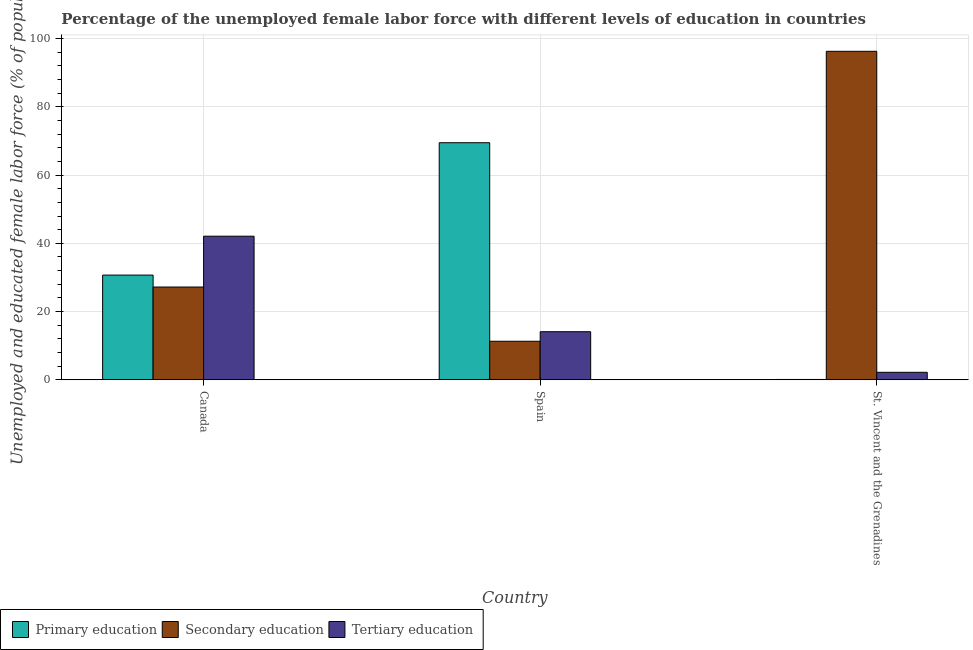How many different coloured bars are there?
Your answer should be very brief. 3. How many groups of bars are there?
Give a very brief answer. 3. How many bars are there on the 3rd tick from the left?
Keep it short and to the point. 3. In how many cases, is the number of bars for a given country not equal to the number of legend labels?
Make the answer very short. 0. What is the percentage of female labor force who received primary education in St. Vincent and the Grenadines?
Your answer should be compact. 0.1. Across all countries, what is the maximum percentage of female labor force who received secondary education?
Your answer should be very brief. 96.3. Across all countries, what is the minimum percentage of female labor force who received tertiary education?
Provide a short and direct response. 2.2. In which country was the percentage of female labor force who received primary education minimum?
Make the answer very short. St. Vincent and the Grenadines. What is the total percentage of female labor force who received secondary education in the graph?
Ensure brevity in your answer.  134.8. What is the difference between the percentage of female labor force who received primary education in Spain and that in St. Vincent and the Grenadines?
Make the answer very short. 69.4. What is the difference between the percentage of female labor force who received primary education in Canada and the percentage of female labor force who received secondary education in Spain?
Provide a short and direct response. 19.4. What is the average percentage of female labor force who received secondary education per country?
Offer a very short reply. 44.93. What is the difference between the percentage of female labor force who received secondary education and percentage of female labor force who received tertiary education in St. Vincent and the Grenadines?
Keep it short and to the point. 94.1. What is the ratio of the percentage of female labor force who received primary education in Canada to that in St. Vincent and the Grenadines?
Ensure brevity in your answer.  307. Is the percentage of female labor force who received secondary education in Canada less than that in Spain?
Offer a terse response. No. What is the difference between the highest and the second highest percentage of female labor force who received secondary education?
Provide a succinct answer. 69.1. What is the difference between the highest and the lowest percentage of female labor force who received primary education?
Provide a short and direct response. 69.4. Is the sum of the percentage of female labor force who received secondary education in Spain and St. Vincent and the Grenadines greater than the maximum percentage of female labor force who received primary education across all countries?
Your answer should be compact. Yes. What does the 1st bar from the left in Canada represents?
Give a very brief answer. Primary education. What does the 2nd bar from the right in St. Vincent and the Grenadines represents?
Keep it short and to the point. Secondary education. Is it the case that in every country, the sum of the percentage of female labor force who received primary education and percentage of female labor force who received secondary education is greater than the percentage of female labor force who received tertiary education?
Your answer should be compact. Yes. Does the graph contain grids?
Your response must be concise. Yes. How many legend labels are there?
Keep it short and to the point. 3. How are the legend labels stacked?
Your answer should be very brief. Horizontal. What is the title of the graph?
Ensure brevity in your answer.  Percentage of the unemployed female labor force with different levels of education in countries. What is the label or title of the X-axis?
Provide a short and direct response. Country. What is the label or title of the Y-axis?
Give a very brief answer. Unemployed and educated female labor force (% of population). What is the Unemployed and educated female labor force (% of population) in Primary education in Canada?
Your response must be concise. 30.7. What is the Unemployed and educated female labor force (% of population) in Secondary education in Canada?
Make the answer very short. 27.2. What is the Unemployed and educated female labor force (% of population) in Tertiary education in Canada?
Your answer should be compact. 42.1. What is the Unemployed and educated female labor force (% of population) of Primary education in Spain?
Offer a very short reply. 69.5. What is the Unemployed and educated female labor force (% of population) in Secondary education in Spain?
Your answer should be compact. 11.3. What is the Unemployed and educated female labor force (% of population) in Tertiary education in Spain?
Provide a succinct answer. 14.1. What is the Unemployed and educated female labor force (% of population) in Primary education in St. Vincent and the Grenadines?
Provide a succinct answer. 0.1. What is the Unemployed and educated female labor force (% of population) in Secondary education in St. Vincent and the Grenadines?
Give a very brief answer. 96.3. What is the Unemployed and educated female labor force (% of population) in Tertiary education in St. Vincent and the Grenadines?
Make the answer very short. 2.2. Across all countries, what is the maximum Unemployed and educated female labor force (% of population) of Primary education?
Provide a succinct answer. 69.5. Across all countries, what is the maximum Unemployed and educated female labor force (% of population) in Secondary education?
Ensure brevity in your answer.  96.3. Across all countries, what is the maximum Unemployed and educated female labor force (% of population) in Tertiary education?
Keep it short and to the point. 42.1. Across all countries, what is the minimum Unemployed and educated female labor force (% of population) of Primary education?
Your answer should be very brief. 0.1. Across all countries, what is the minimum Unemployed and educated female labor force (% of population) of Secondary education?
Give a very brief answer. 11.3. Across all countries, what is the minimum Unemployed and educated female labor force (% of population) of Tertiary education?
Provide a short and direct response. 2.2. What is the total Unemployed and educated female labor force (% of population) of Primary education in the graph?
Keep it short and to the point. 100.3. What is the total Unemployed and educated female labor force (% of population) in Secondary education in the graph?
Your answer should be compact. 134.8. What is the total Unemployed and educated female labor force (% of population) of Tertiary education in the graph?
Your answer should be compact. 58.4. What is the difference between the Unemployed and educated female labor force (% of population) of Primary education in Canada and that in Spain?
Offer a very short reply. -38.8. What is the difference between the Unemployed and educated female labor force (% of population) of Tertiary education in Canada and that in Spain?
Offer a terse response. 28. What is the difference between the Unemployed and educated female labor force (% of population) in Primary education in Canada and that in St. Vincent and the Grenadines?
Provide a short and direct response. 30.6. What is the difference between the Unemployed and educated female labor force (% of population) of Secondary education in Canada and that in St. Vincent and the Grenadines?
Offer a terse response. -69.1. What is the difference between the Unemployed and educated female labor force (% of population) of Tertiary education in Canada and that in St. Vincent and the Grenadines?
Your answer should be very brief. 39.9. What is the difference between the Unemployed and educated female labor force (% of population) of Primary education in Spain and that in St. Vincent and the Grenadines?
Offer a very short reply. 69.4. What is the difference between the Unemployed and educated female labor force (% of population) of Secondary education in Spain and that in St. Vincent and the Grenadines?
Your answer should be compact. -85. What is the difference between the Unemployed and educated female labor force (% of population) of Tertiary education in Spain and that in St. Vincent and the Grenadines?
Offer a very short reply. 11.9. What is the difference between the Unemployed and educated female labor force (% of population) of Primary education in Canada and the Unemployed and educated female labor force (% of population) of Secondary education in Spain?
Your answer should be very brief. 19.4. What is the difference between the Unemployed and educated female labor force (% of population) of Primary education in Canada and the Unemployed and educated female labor force (% of population) of Secondary education in St. Vincent and the Grenadines?
Offer a terse response. -65.6. What is the difference between the Unemployed and educated female labor force (% of population) in Primary education in Canada and the Unemployed and educated female labor force (% of population) in Tertiary education in St. Vincent and the Grenadines?
Ensure brevity in your answer.  28.5. What is the difference between the Unemployed and educated female labor force (% of population) in Primary education in Spain and the Unemployed and educated female labor force (% of population) in Secondary education in St. Vincent and the Grenadines?
Your answer should be very brief. -26.8. What is the difference between the Unemployed and educated female labor force (% of population) of Primary education in Spain and the Unemployed and educated female labor force (% of population) of Tertiary education in St. Vincent and the Grenadines?
Offer a very short reply. 67.3. What is the average Unemployed and educated female labor force (% of population) of Primary education per country?
Your response must be concise. 33.43. What is the average Unemployed and educated female labor force (% of population) in Secondary education per country?
Your answer should be compact. 44.93. What is the average Unemployed and educated female labor force (% of population) in Tertiary education per country?
Provide a short and direct response. 19.47. What is the difference between the Unemployed and educated female labor force (% of population) of Primary education and Unemployed and educated female labor force (% of population) of Tertiary education in Canada?
Your answer should be very brief. -11.4. What is the difference between the Unemployed and educated female labor force (% of population) of Secondary education and Unemployed and educated female labor force (% of population) of Tertiary education in Canada?
Make the answer very short. -14.9. What is the difference between the Unemployed and educated female labor force (% of population) in Primary education and Unemployed and educated female labor force (% of population) in Secondary education in Spain?
Give a very brief answer. 58.2. What is the difference between the Unemployed and educated female labor force (% of population) of Primary education and Unemployed and educated female labor force (% of population) of Tertiary education in Spain?
Your answer should be very brief. 55.4. What is the difference between the Unemployed and educated female labor force (% of population) of Secondary education and Unemployed and educated female labor force (% of population) of Tertiary education in Spain?
Your answer should be very brief. -2.8. What is the difference between the Unemployed and educated female labor force (% of population) of Primary education and Unemployed and educated female labor force (% of population) of Secondary education in St. Vincent and the Grenadines?
Make the answer very short. -96.2. What is the difference between the Unemployed and educated female labor force (% of population) of Primary education and Unemployed and educated female labor force (% of population) of Tertiary education in St. Vincent and the Grenadines?
Ensure brevity in your answer.  -2.1. What is the difference between the Unemployed and educated female labor force (% of population) in Secondary education and Unemployed and educated female labor force (% of population) in Tertiary education in St. Vincent and the Grenadines?
Keep it short and to the point. 94.1. What is the ratio of the Unemployed and educated female labor force (% of population) of Primary education in Canada to that in Spain?
Your answer should be very brief. 0.44. What is the ratio of the Unemployed and educated female labor force (% of population) in Secondary education in Canada to that in Spain?
Your answer should be very brief. 2.41. What is the ratio of the Unemployed and educated female labor force (% of population) of Tertiary education in Canada to that in Spain?
Provide a short and direct response. 2.99. What is the ratio of the Unemployed and educated female labor force (% of population) in Primary education in Canada to that in St. Vincent and the Grenadines?
Make the answer very short. 307. What is the ratio of the Unemployed and educated female labor force (% of population) of Secondary education in Canada to that in St. Vincent and the Grenadines?
Ensure brevity in your answer.  0.28. What is the ratio of the Unemployed and educated female labor force (% of population) of Tertiary education in Canada to that in St. Vincent and the Grenadines?
Offer a very short reply. 19.14. What is the ratio of the Unemployed and educated female labor force (% of population) in Primary education in Spain to that in St. Vincent and the Grenadines?
Provide a succinct answer. 695. What is the ratio of the Unemployed and educated female labor force (% of population) of Secondary education in Spain to that in St. Vincent and the Grenadines?
Provide a short and direct response. 0.12. What is the ratio of the Unemployed and educated female labor force (% of population) in Tertiary education in Spain to that in St. Vincent and the Grenadines?
Your response must be concise. 6.41. What is the difference between the highest and the second highest Unemployed and educated female labor force (% of population) of Primary education?
Keep it short and to the point. 38.8. What is the difference between the highest and the second highest Unemployed and educated female labor force (% of population) in Secondary education?
Keep it short and to the point. 69.1. What is the difference between the highest and the second highest Unemployed and educated female labor force (% of population) of Tertiary education?
Give a very brief answer. 28. What is the difference between the highest and the lowest Unemployed and educated female labor force (% of population) of Primary education?
Offer a terse response. 69.4. What is the difference between the highest and the lowest Unemployed and educated female labor force (% of population) in Secondary education?
Keep it short and to the point. 85. What is the difference between the highest and the lowest Unemployed and educated female labor force (% of population) of Tertiary education?
Your answer should be compact. 39.9. 